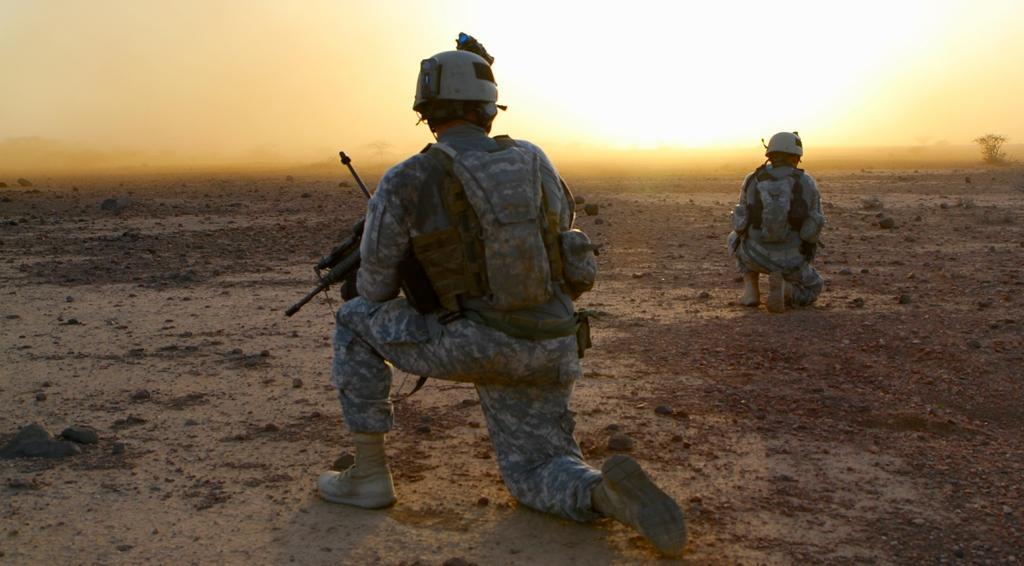How would you summarize this image in a sentence or two? In this image there is a ground with sand. There are two people. There is a tree on the right side. There is a sky. 